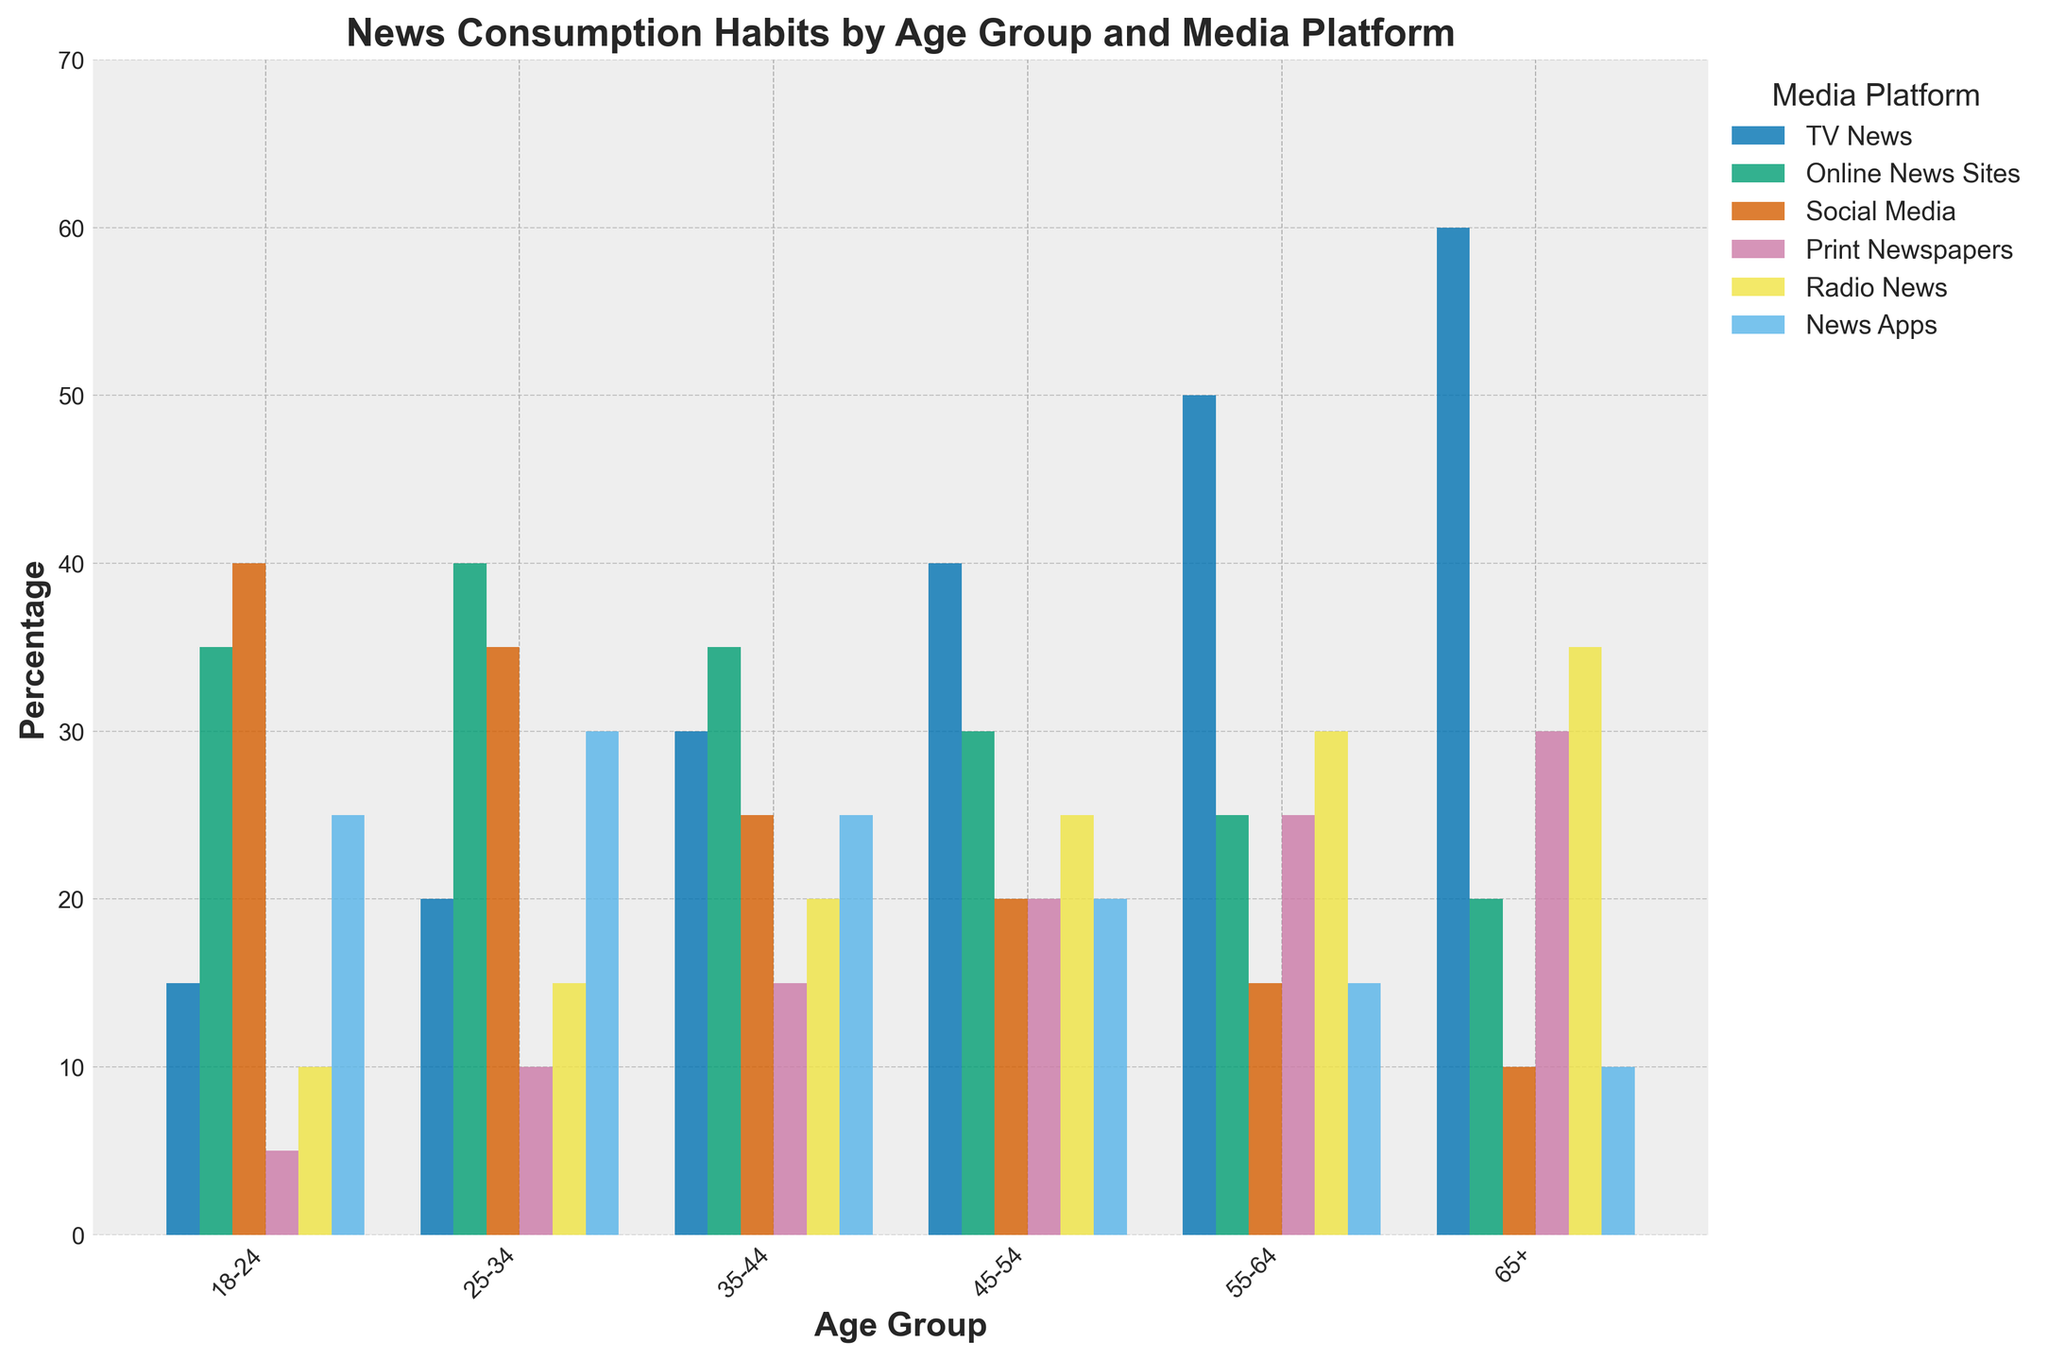What's the most popular news platform for the 18-24 age group? To determine the answer, look at the bars representing each platform for the 18-24 age group and identify the one with the highest value. The 'Social Media' bar is the tallest at 40%.
Answer: Social Media Which age group prefers TV News the most? Compare the heights of the 'TV News' bars across all age groups. The 'TV News' bar is the highest for the 65+ age group at 60%.
Answer: 65+ What's the difference in print newspaper consumption between the 25-34 and 65+ age groups? Look at the 'Print Newspapers' bars for both the 25-34 and 65+ age groups. The height for the 25-34 age group is 10%, and for the 65+ age group, it is 30%. Calculate the difference: 30% - 10% = 20%.
Answer: 20% Which age group has the least consumption of news apps? Observe the heights of the 'News Apps' bars for all age groups and find the smallest. The 'News Apps' bar is the shortest for the 65+ age group at 10%.
Answer: 65+ Is the consumption of radio news higher in the 45-54 age group compared to the 18-24 age group? Compare the heights of the 'Radio News' bars for the 45-54 and 18-24 age groups. The 45-54 age group has a bar at 25%, whereas the 18-24 age group has a bar at 10%.
Answer: Yes How many age groups have a higher percentage of consumption for online news sites compared to print newspapers? Compare the heights of the 'Online News Sites' and 'Print Newspapers' bars for each age group. The 18-24, 25-34, and 35-44 age groups have higher 'Online News Sites' values than 'Print Newspapers', making a total of three age groups.
Answer: 3 What's the average consumption percentage of social media news across all age groups? Add the percentages for social media consumption across all age groups: 40% + 35% + 25% + 20% + 15% + 10%, which equals 145%. Divide by the number of age groups (6): 145% / 6 ≈ 24.17%.
Answer: 24.17% Which media platform shows a decreasing trend in consumption as the age increases? Observe how the bars change in height across age groups. The 'Social Media' bars decrease from 40% in the 18-24 age group to 10% in the 65+ age group.
Answer: Social Media 